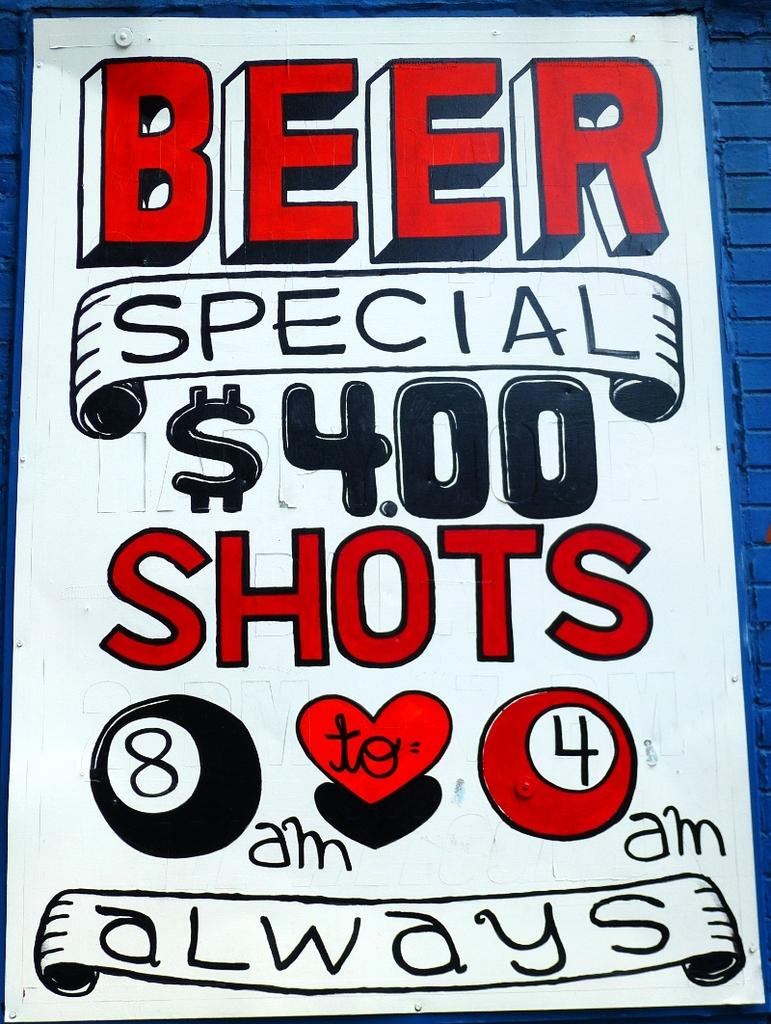<image>
Relay a brief, clear account of the picture shown. Hand written Beer special $4.00 shots on the side of a blue shingled roof. 